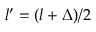<formula> <loc_0><loc_0><loc_500><loc_500>l ^ { \prime } = ( l + \Delta ) / 2</formula> 